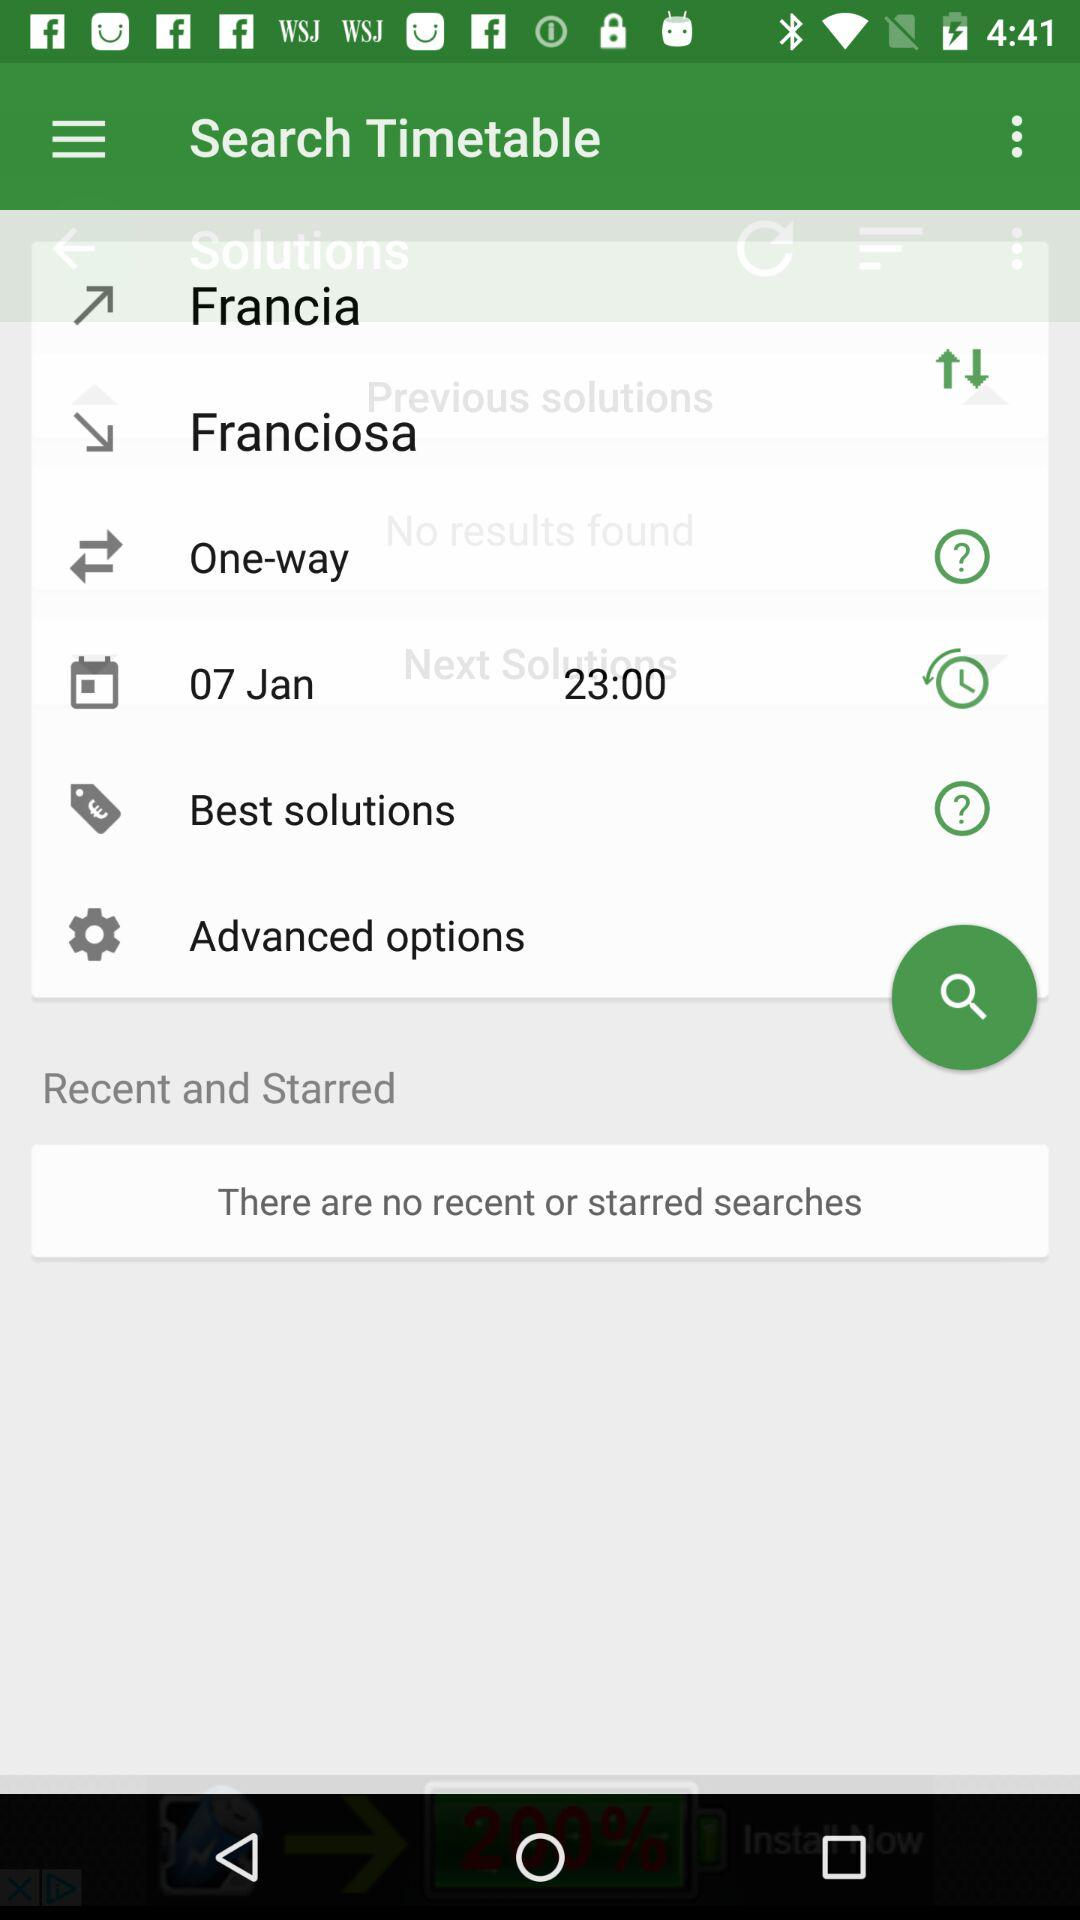What time is shown on the screen? The time shown on the screen is 23:00. 